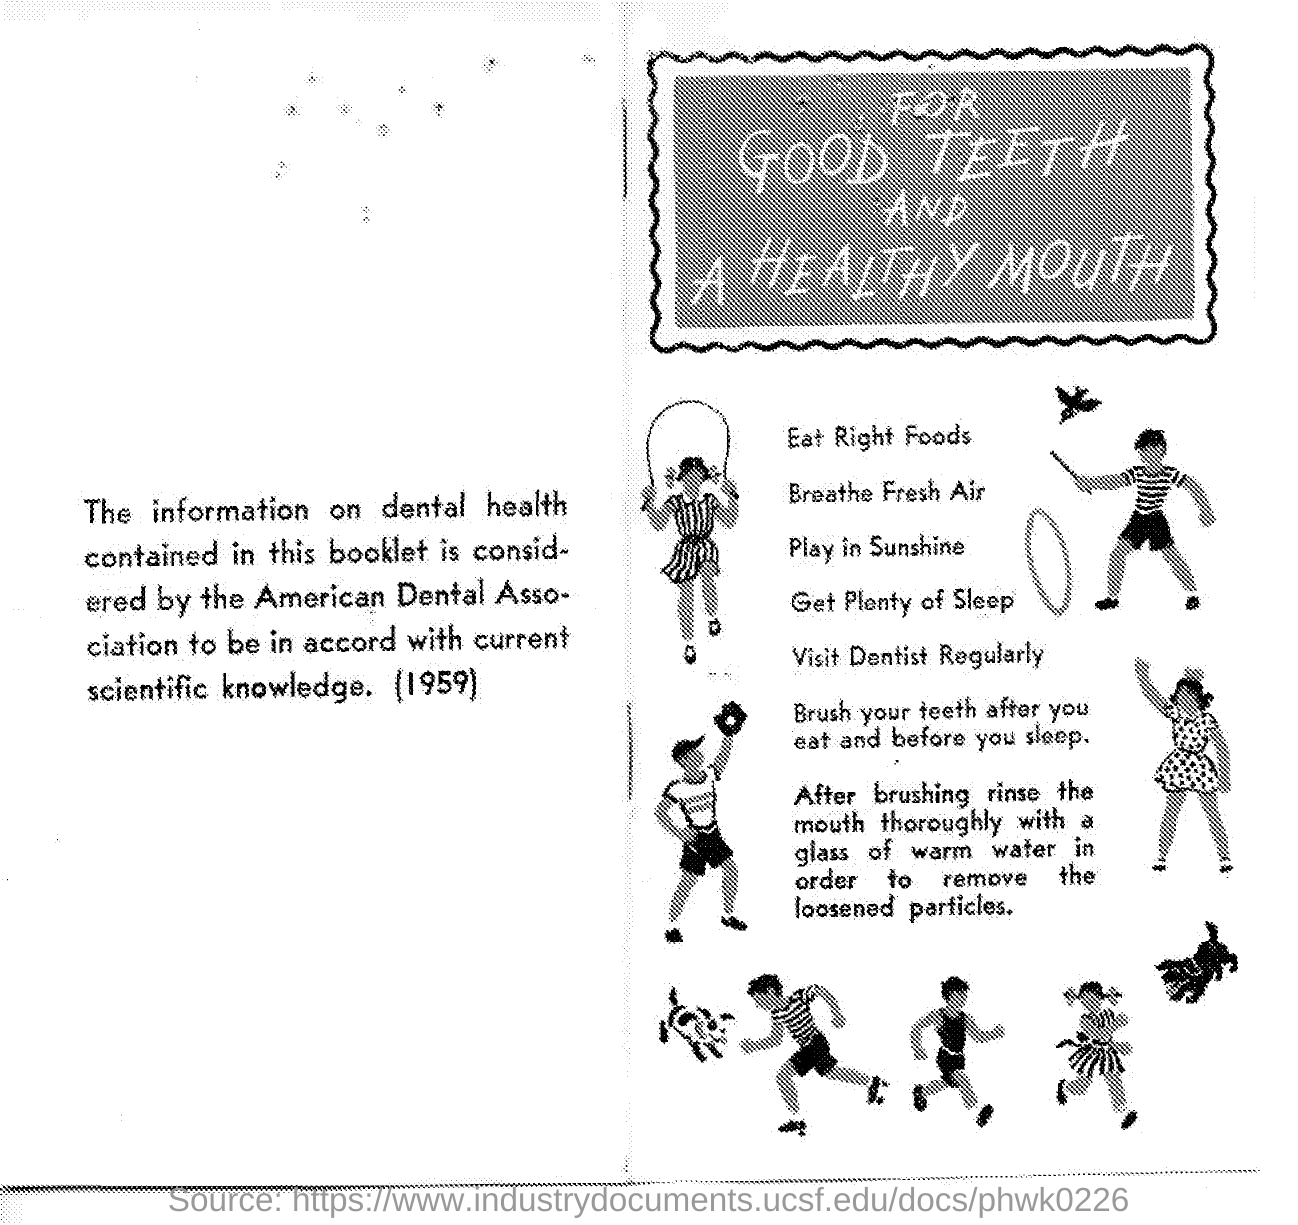Point out several critical features in this image. The title of the document is 'For Good Teeth and a Healthy Mouth.' The year mentioned in the document is 1959. 